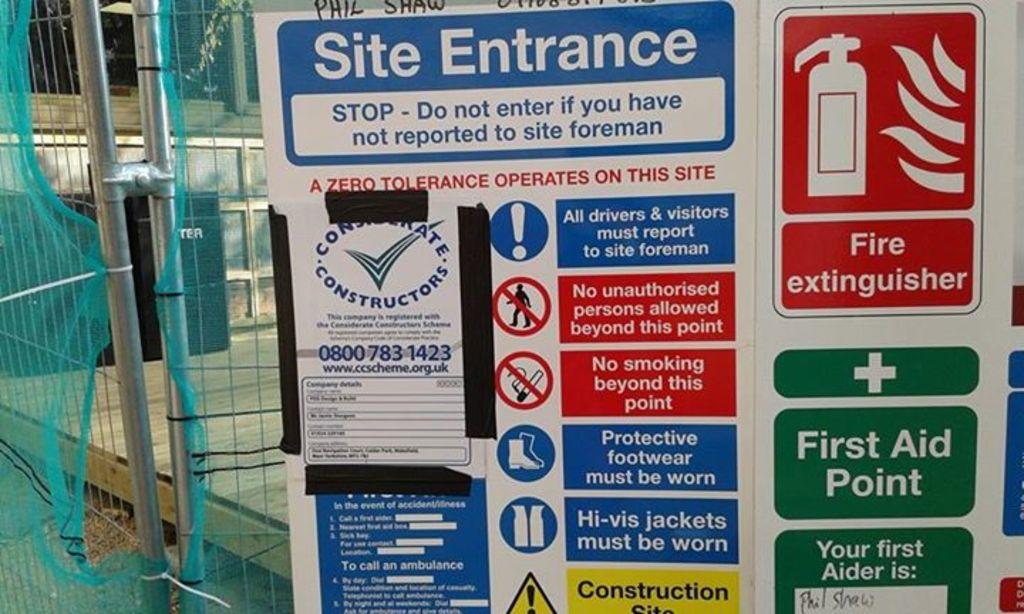What does the red sign signal?
Ensure brevity in your answer.  Fire extinguisher. What is written in blue on the top of the sign?
Offer a very short reply. Site entrance. 